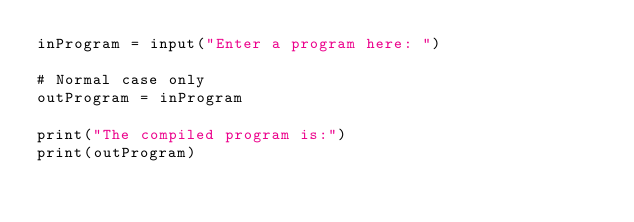<code> <loc_0><loc_0><loc_500><loc_500><_Python_>inProgram = input("Enter a program here: ")

# Normal case only
outProgram = inProgram

print("The compiled program is:")
print(outProgram)
</code> 